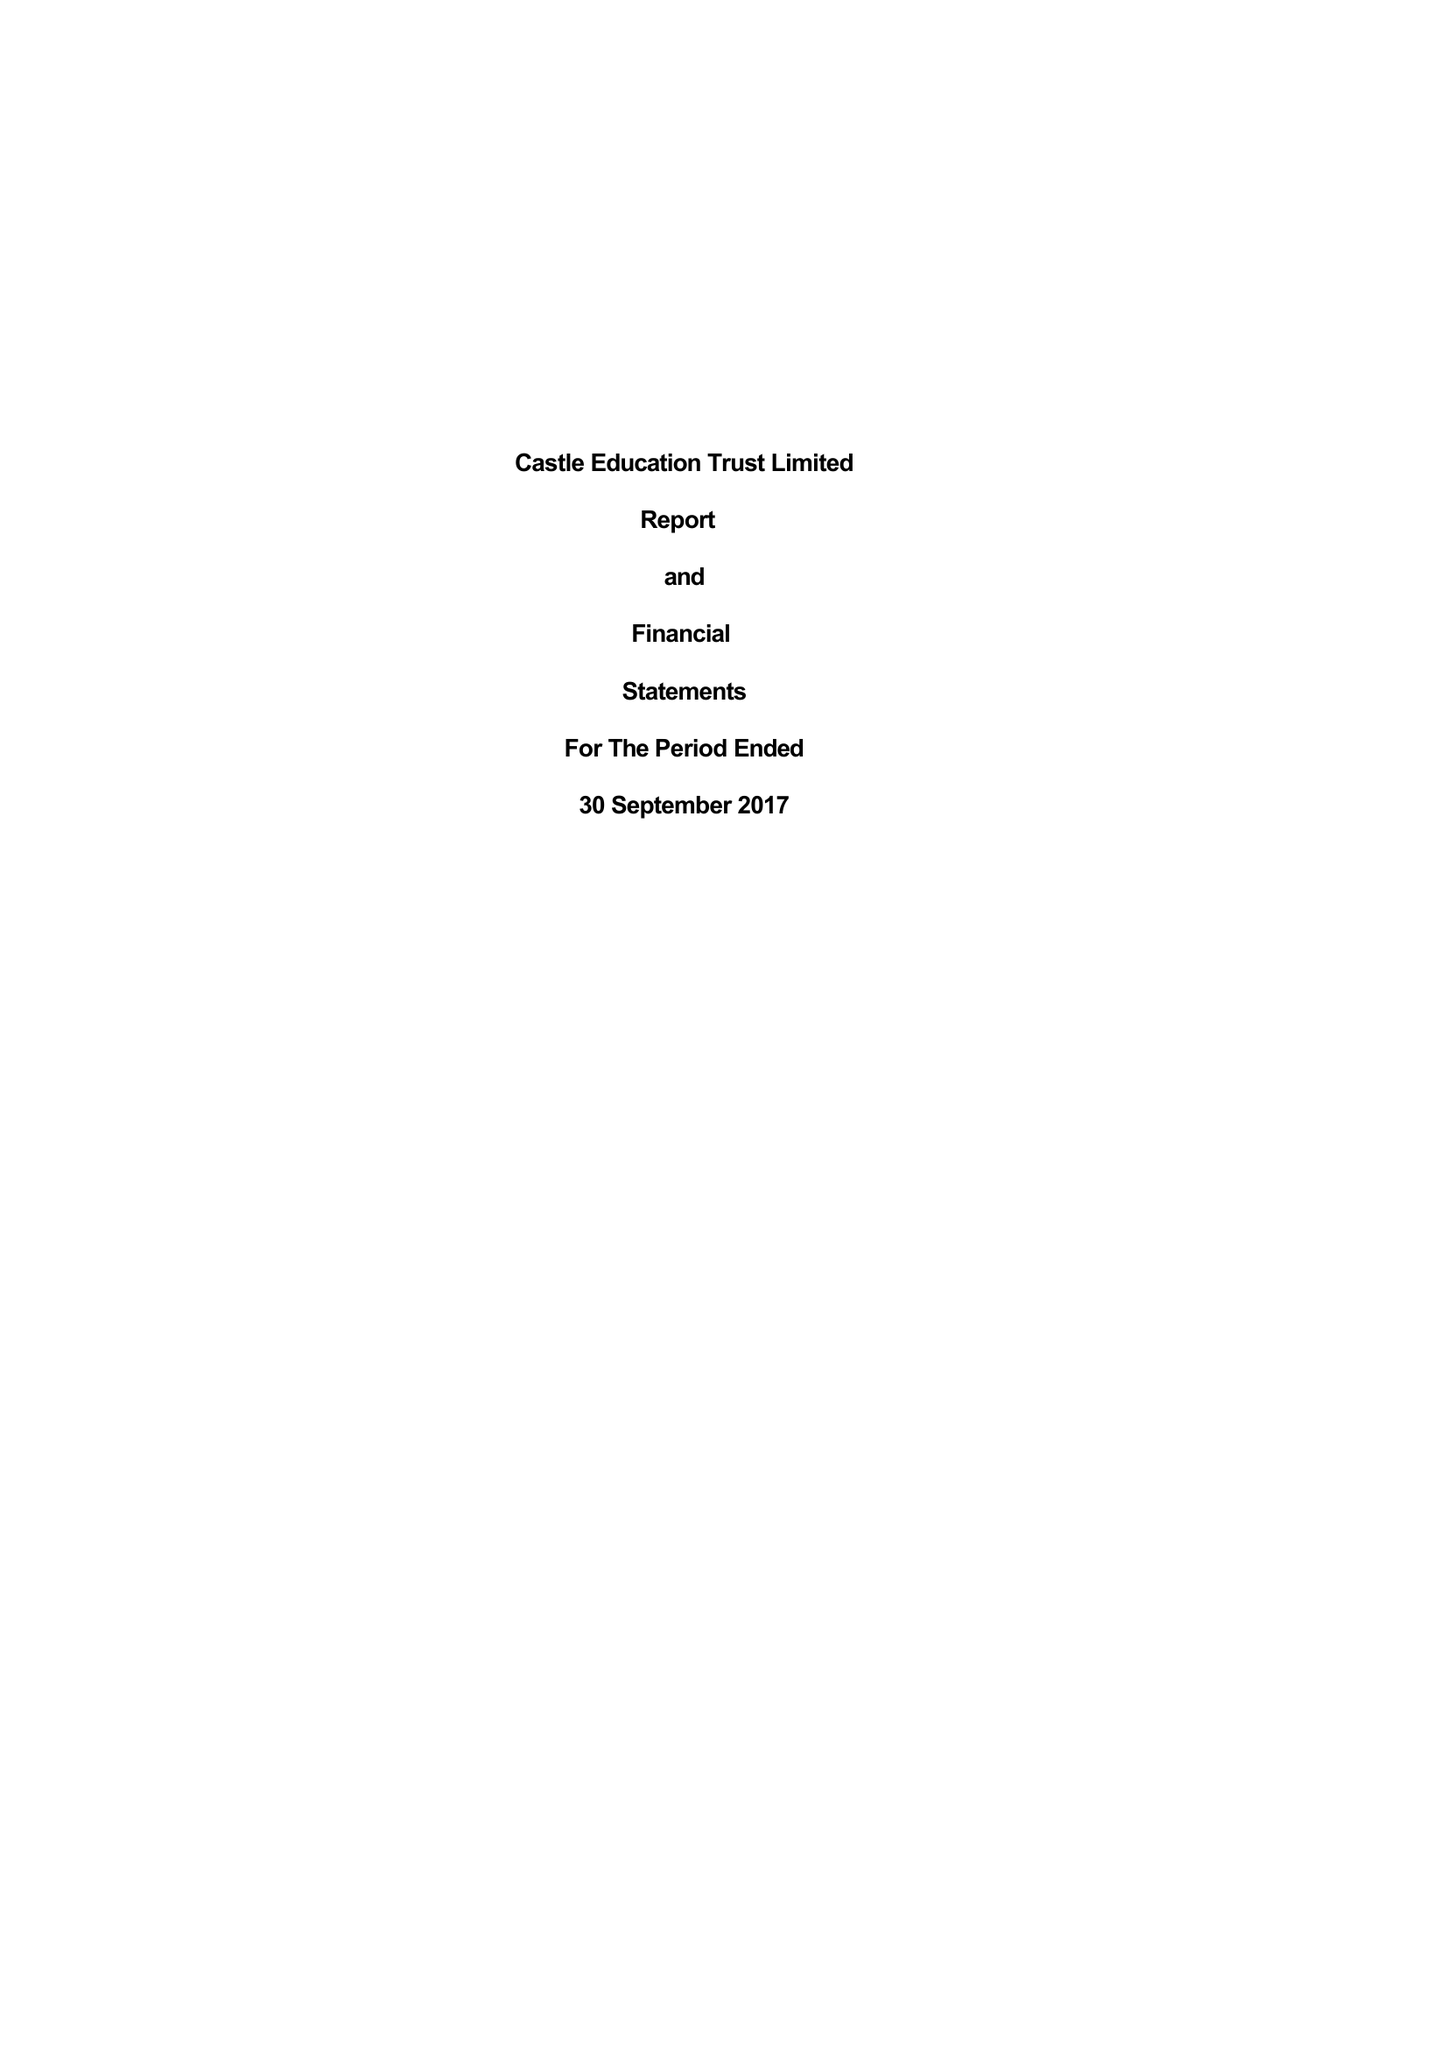What is the value for the charity_number?
Answer the question using a single word or phrase. 1146738 